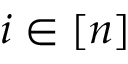<formula> <loc_0><loc_0><loc_500><loc_500>i \in [ n ]</formula> 